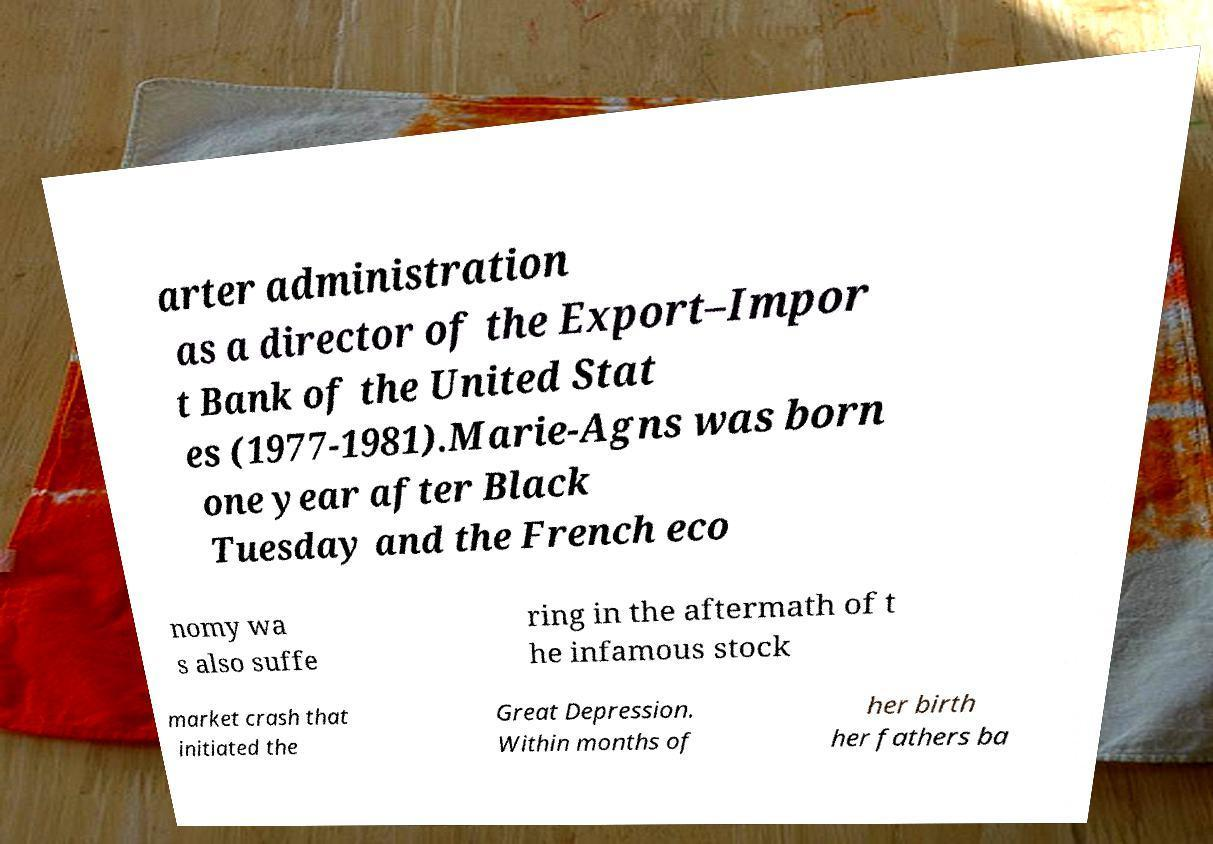Can you accurately transcribe the text from the provided image for me? arter administration as a director of the Export–Impor t Bank of the United Stat es (1977-1981).Marie-Agns was born one year after Black Tuesday and the French eco nomy wa s also suffe ring in the aftermath of t he infamous stock market crash that initiated the Great Depression. Within months of her birth her fathers ba 